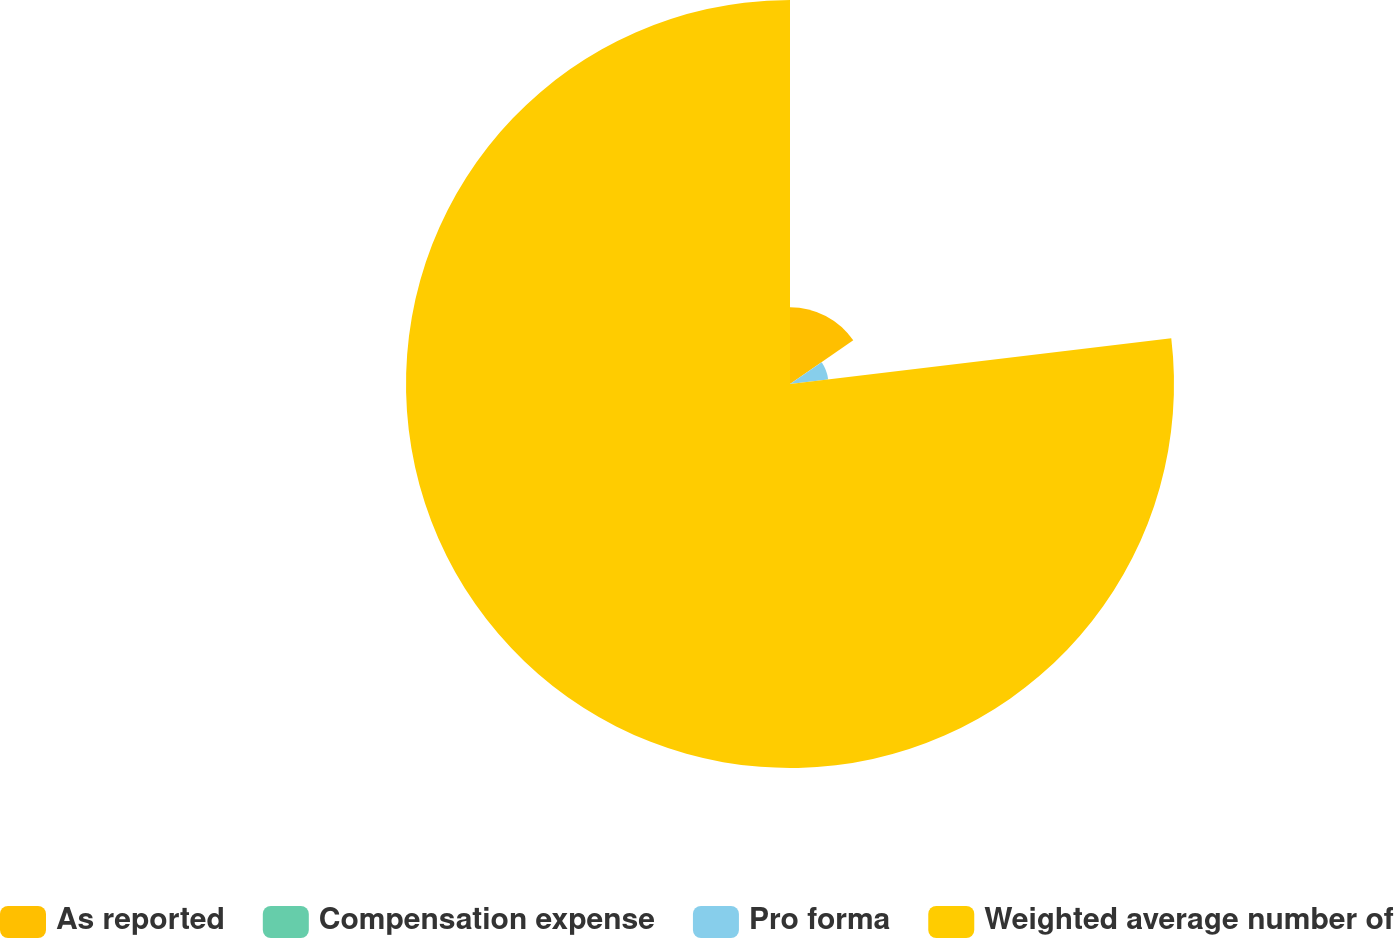<chart> <loc_0><loc_0><loc_500><loc_500><pie_chart><fcel>As reported<fcel>Compensation expense<fcel>Pro forma<fcel>Weighted average number of<nl><fcel>15.39%<fcel>0.01%<fcel>7.7%<fcel>76.9%<nl></chart> 